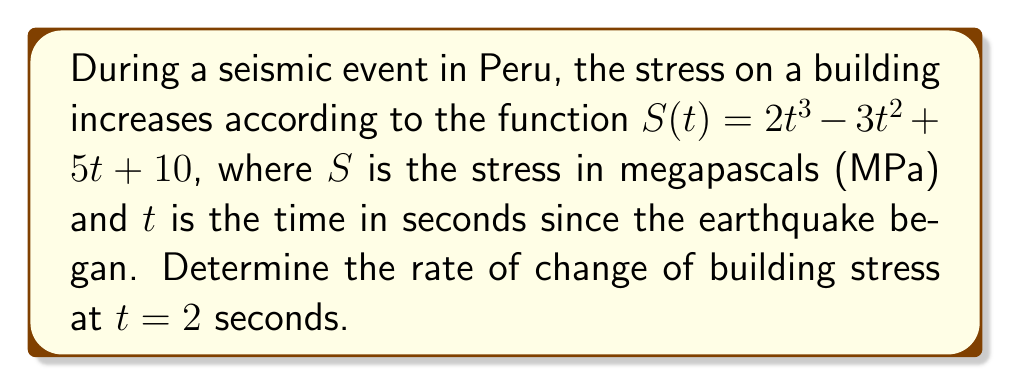Show me your answer to this math problem. To find the rate of change of building stress at a specific time, we need to calculate the derivative of the stress function $S(t)$ and then evaluate it at the given time.

1. The stress function is given as:
   $S(t) = 2t^3 - 3t^2 + 5t + 10$

2. To find the rate of change, we need to calculate $\frac{dS}{dt}$:
   $$\begin{align}
   \frac{dS}{dt} &= \frac{d}{dt}(2t^3 - 3t^2 + 5t + 10) \\
   &= 6t^2 - 6t + 5
   \end{align}$$

3. Now that we have the derivative, we can evaluate it at $t = 2$ seconds:
   $$\begin{align}
   \frac{dS}{dt}\bigg|_{t=2} &= 6(2)^2 - 6(2) + 5 \\
   &= 6(4) - 12 + 5 \\
   &= 24 - 12 + 5 \\
   &= 17
   \end{align}$$

Therefore, the rate of change of building stress at $t = 2$ seconds is 17 MPa/s.
Answer: 17 MPa/s 